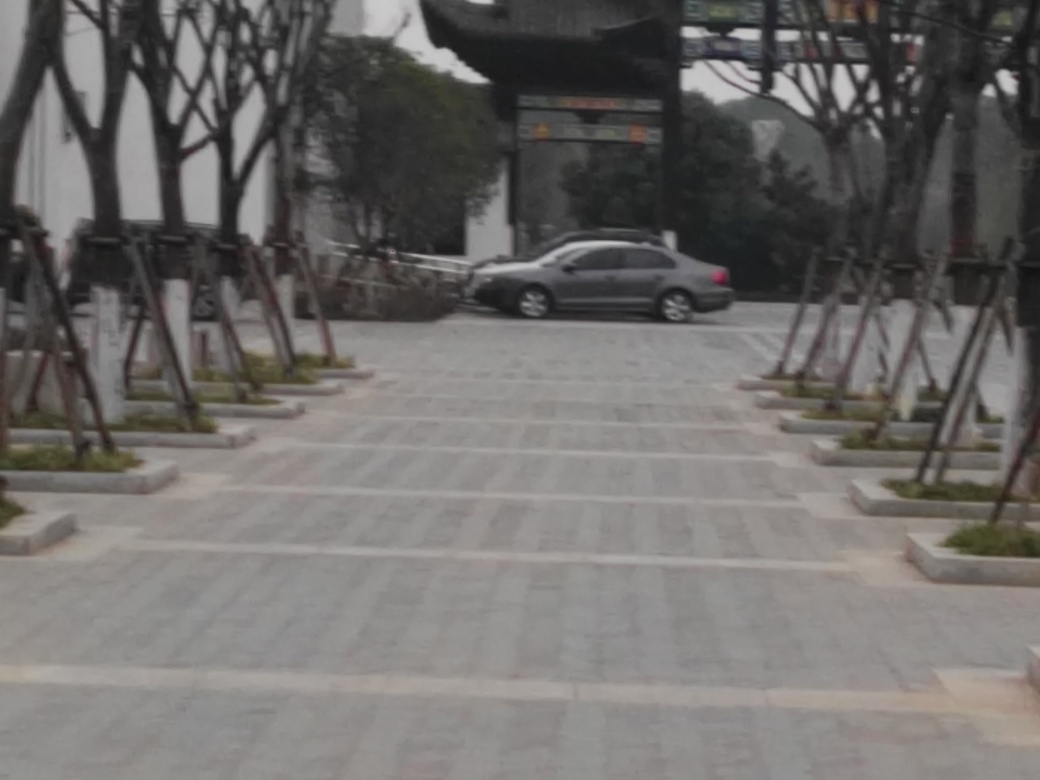Is the image well-focused? The image appears to be slightly out of focus, which affects the sharpness and clarity of the details, such as the car in the distance and the surrounding trees. 